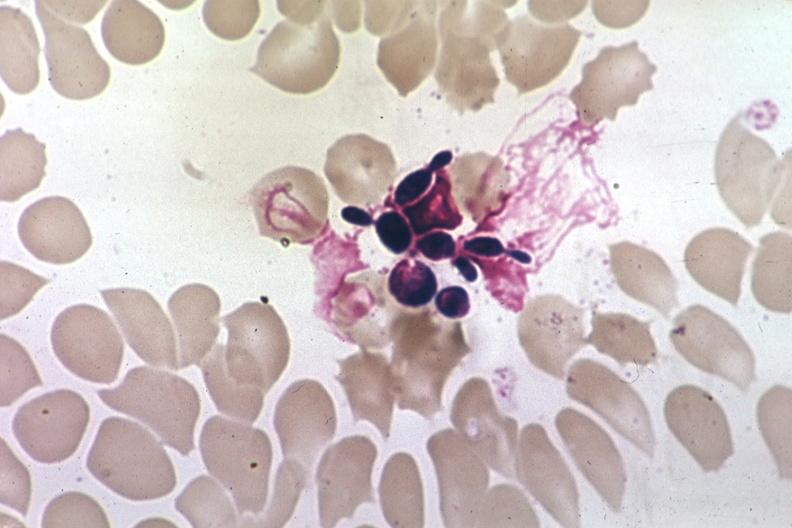s thymoma present?
Answer the question using a single word or phrase. No 